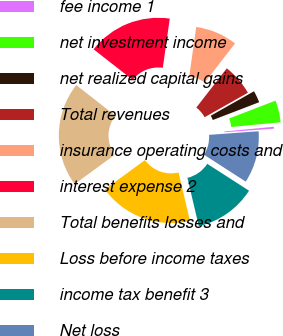Convert chart. <chart><loc_0><loc_0><loc_500><loc_500><pie_chart><fcel>fee income 1<fcel>net investment income<fcel>net realized capital gains<fcel>Total revenues<fcel>insurance operating costs and<fcel>interest expense 2<fcel>Total benefits losses and<fcel>Loss before income taxes<fcel>income tax benefit 3<fcel>Net loss<nl><fcel>0.37%<fcel>4.32%<fcel>2.35%<fcel>6.3%<fcel>8.27%<fcel>16.67%<fcel>20.61%<fcel>18.64%<fcel>12.22%<fcel>10.25%<nl></chart> 